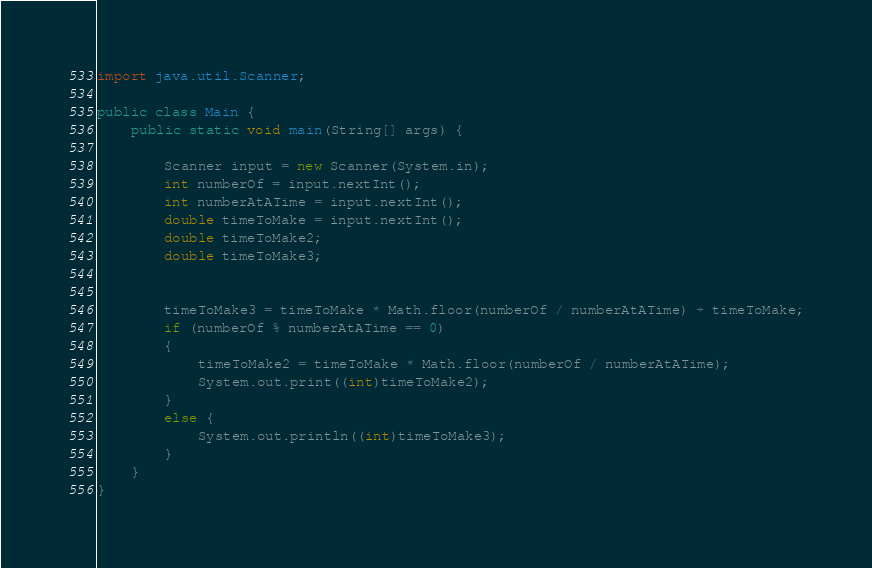Convert code to text. <code><loc_0><loc_0><loc_500><loc_500><_Java_>import java.util.Scanner;

public class Main {
    public static void main(String[] args) {

        Scanner input = new Scanner(System.in);
        int numberOf = input.nextInt();
        int numberAtATime = input.nextInt();
        double timeToMake = input.nextInt();
        double timeToMake2;
        double timeToMake3;


        timeToMake3 = timeToMake * Math.floor(numberOf / numberAtATime) + timeToMake;
        if (numberOf % numberAtATime == 0)
        {
            timeToMake2 = timeToMake * Math.floor(numberOf / numberAtATime);
            System.out.print((int)timeToMake2);
        }
        else {
            System.out.println((int)timeToMake3);
        }
    }
}</code> 